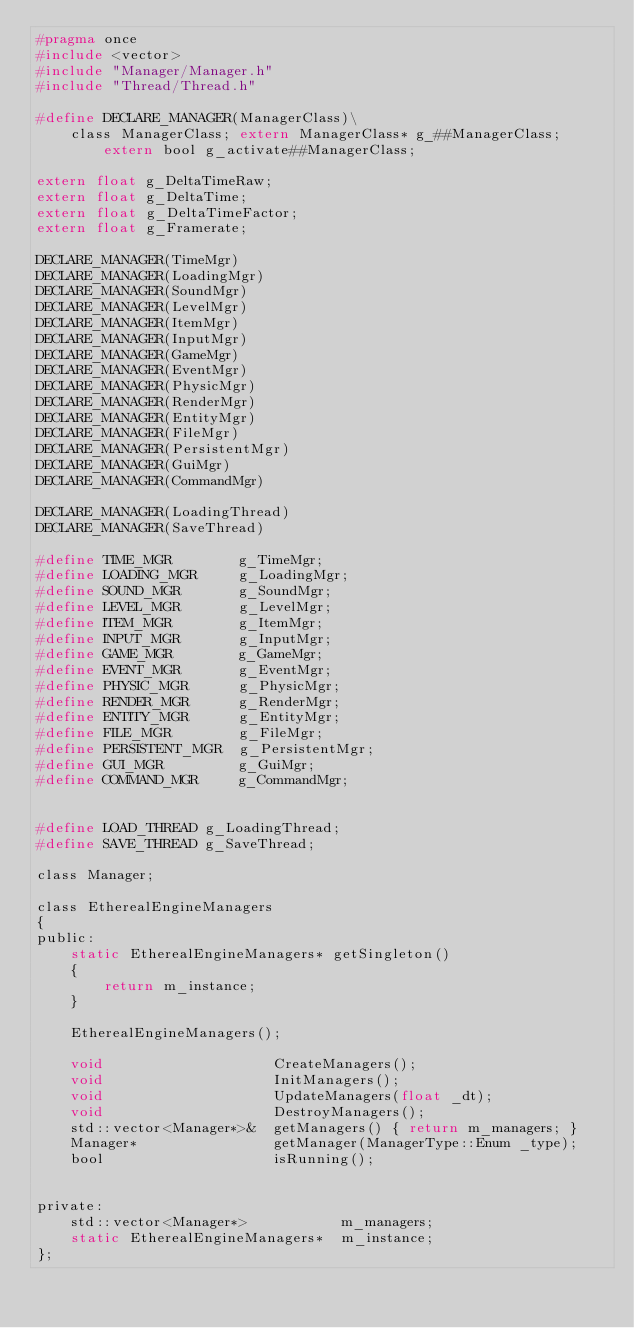Convert code to text. <code><loc_0><loc_0><loc_500><loc_500><_C_>#pragma once
#include <vector>
#include "Manager/Manager.h"
#include "Thread/Thread.h"

#define DECLARE_MANAGER(ManagerClass)\
	class ManagerClass; extern ManagerClass* g_##ManagerClass; extern bool g_activate##ManagerClass;

extern float g_DeltaTimeRaw;
extern float g_DeltaTime;
extern float g_DeltaTimeFactor;
extern float g_Framerate;

DECLARE_MANAGER(TimeMgr)
DECLARE_MANAGER(LoadingMgr)
DECLARE_MANAGER(SoundMgr)
DECLARE_MANAGER(LevelMgr)
DECLARE_MANAGER(ItemMgr)
DECLARE_MANAGER(InputMgr)
DECLARE_MANAGER(GameMgr)
DECLARE_MANAGER(EventMgr)
DECLARE_MANAGER(PhysicMgr)
DECLARE_MANAGER(RenderMgr)
DECLARE_MANAGER(EntityMgr)
DECLARE_MANAGER(FileMgr)
DECLARE_MANAGER(PersistentMgr)
DECLARE_MANAGER(GuiMgr)
DECLARE_MANAGER(CommandMgr)

DECLARE_MANAGER(LoadingThread)
DECLARE_MANAGER(SaveThread)

#define TIME_MGR		g_TimeMgr;
#define LOADING_MGR		g_LoadingMgr;
#define SOUND_MGR		g_SoundMgr;
#define LEVEL_MGR		g_LevelMgr;
#define ITEM_MGR		g_ItemMgr;
#define INPUT_MGR		g_InputMgr;
#define GAME_MGR		g_GameMgr;
#define EVENT_MGR		g_EventMgr;
#define PHYSIC_MGR		g_PhysicMgr;
#define RENDER_MGR		g_RenderMgr;
#define ENTITY_MGR		g_EntityMgr;
#define FILE_MGR		g_FileMgr;
#define PERSISTENT_MGR	g_PersistentMgr;
#define GUI_MGR			g_GuiMgr;
#define COMMAND_MGR		g_CommandMgr;


#define LOAD_THREAD	g_LoadingThread;
#define SAVE_THREAD g_SaveThread;

class Manager;

class EtherealEngineManagers
{
public:
	static EtherealEngineManagers* getSingleton()
	{
		return m_instance;
	}

	EtherealEngineManagers();

	void					CreateManagers();
	void					InitManagers();
	void					UpdateManagers(float _dt);
	void					DestroyManagers();
	std::vector<Manager*>&	getManagers() { return m_managers; }
	Manager*				getManager(ManagerType::Enum _type);
	bool					isRunning();


private:
	std::vector<Manager*>			m_managers;
	static EtherealEngineManagers*	m_instance;
};</code> 